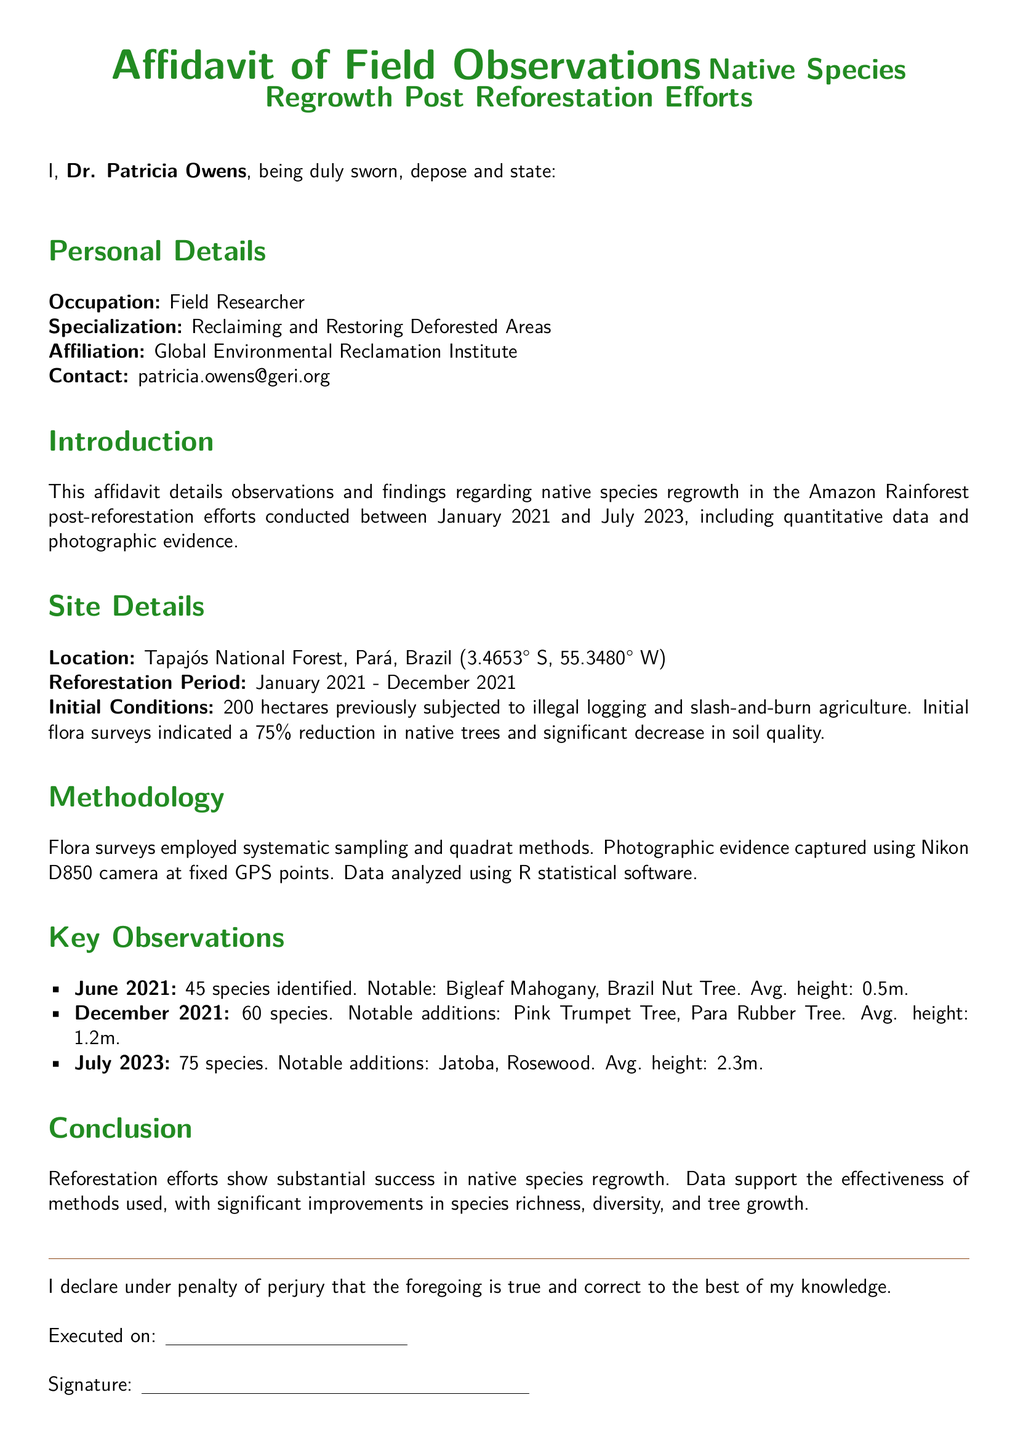What is the name of the researcher? The document specifies that the researcher is Dr. Patricia Owens.
Answer: Dr. Patricia Owens What is the location of the reforestation effort? The affidavit describes the location as Tapajós National Forest, Pará, Brazil.
Answer: Tapajós National Forest, Pará, Brazil How many species were identified in June 2021? The document states that 45 species were identified in June 2021.
Answer: 45 What was the average height of species in July 2023? The affidavit reports that the average height of species was 2.3 meters in July 2023.
Answer: 2.3m What was the initial reduction in native trees? The document mentions a 75% reduction in native trees due to previous activities.
Answer: 75% What was the reforestation period? The affidavit indicates that the reforestation period was from January 2021 to December 2021.
Answer: January 2021 - December 2021 What is the occupation of Dr. Patricia Owens? The document lists her occupation as Field Researcher.
Answer: Field Researcher What notable addition to species occurred by December 2021? The affidavit mentions Pink Trumpet Tree and Para Rubber Tree as notable additions.
Answer: Pink Trumpet Tree, Para Rubber Tree How many species were present in December 2021? The document states that there were 60 species identified by December 2021.
Answer: 60 